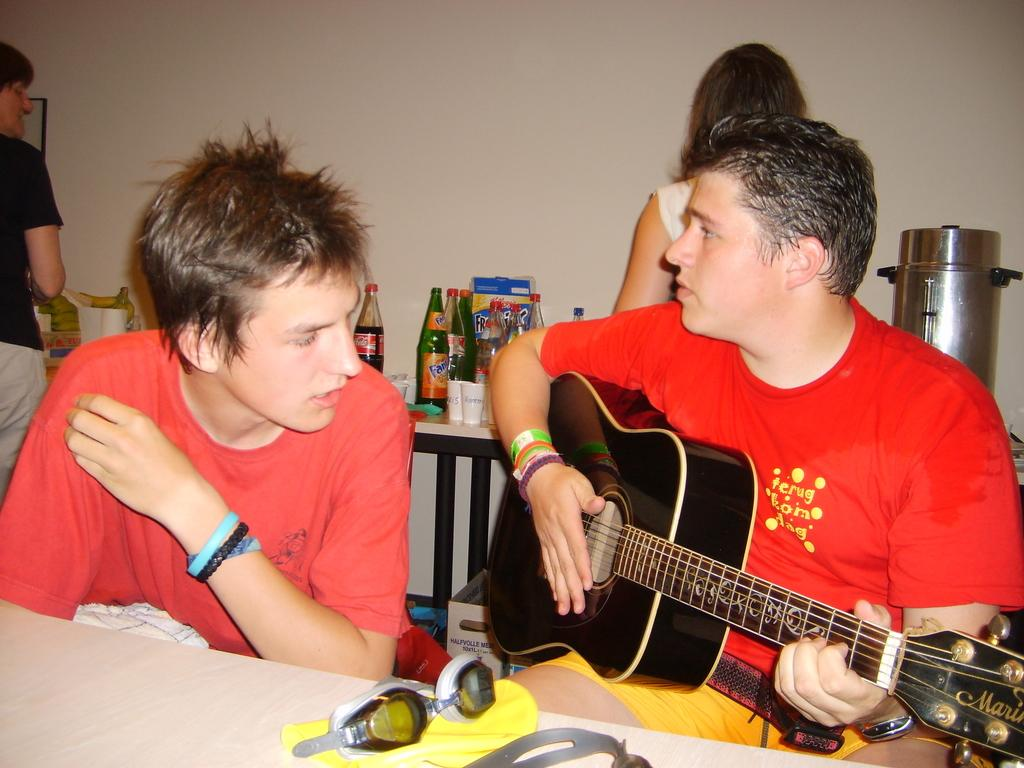What is the person in the image wearing? The person is wearing yellow shorts in the image. What is the person with yellow shorts holding? The person is holding a guitar. Can you describe the position of the other person in the image? There is another person sitting beside the person with the guitar. How many people are standing behind the person with the guitar? There are two persons standing behind the person with the guitar. What is the level of pollution in the image? There is no information about pollution in the image, as it features people and a guitar. 